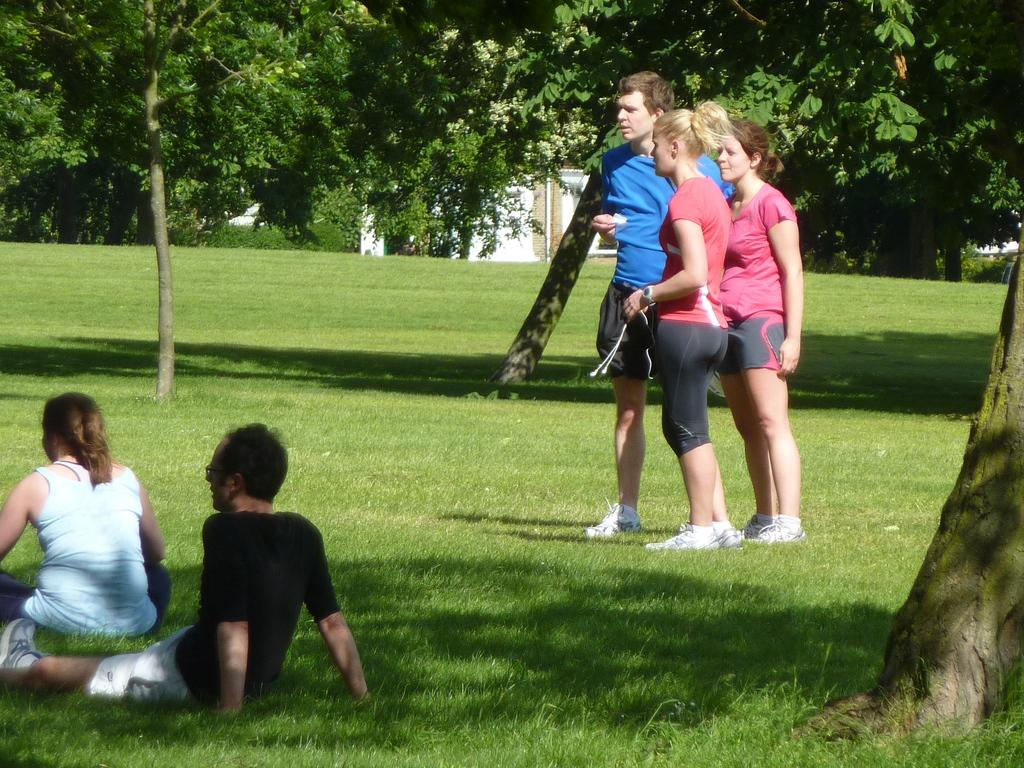What is the setting of the image? The setting of the image is outdoors, with people in the grass. What type of natural elements can be seen in the image? There are trees in the image. What type of man-made structure is visible in the image? There is a building in the image. What type of vegetable is being used as a prop in the image? There is no vegetable present in the image. How many screws can be seen holding the building together in the image? There is no visible indication of screws holding the building together in the image. 